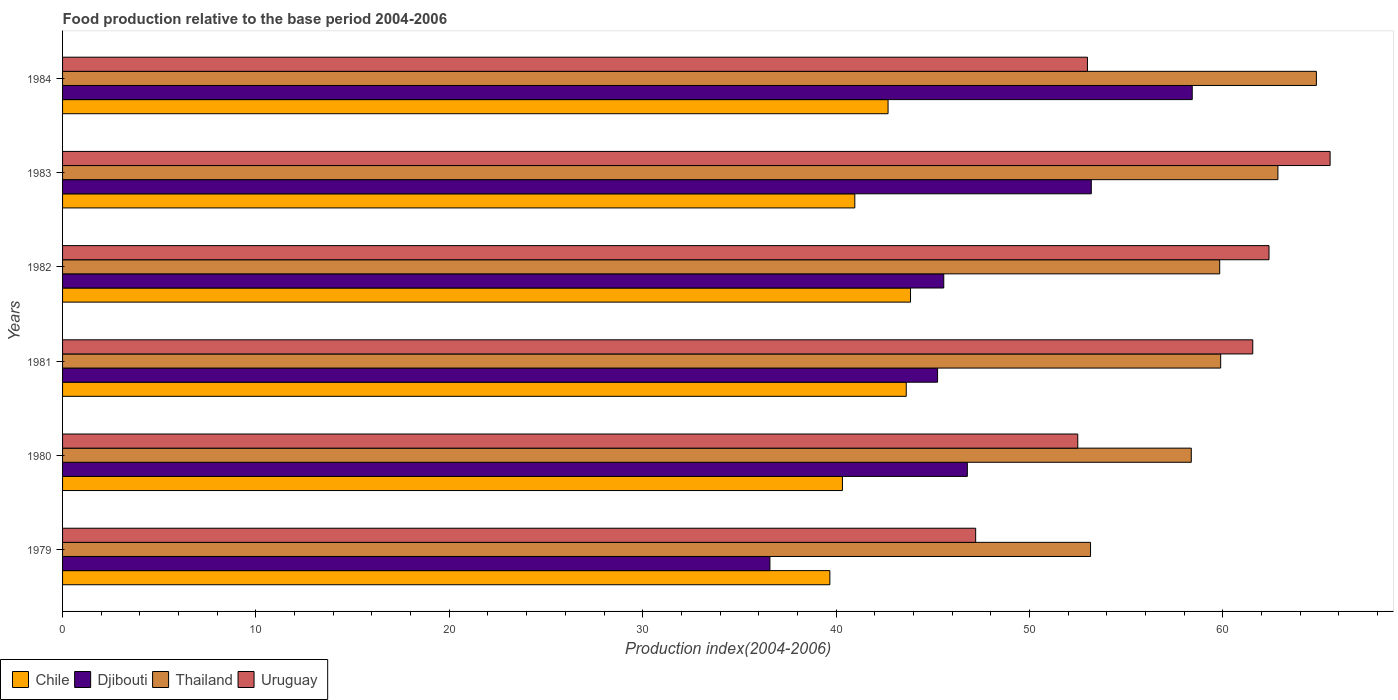How many different coloured bars are there?
Give a very brief answer. 4. Are the number of bars per tick equal to the number of legend labels?
Offer a terse response. Yes. Are the number of bars on each tick of the Y-axis equal?
Ensure brevity in your answer.  Yes. How many bars are there on the 3rd tick from the top?
Provide a succinct answer. 4. How many bars are there on the 6th tick from the bottom?
Offer a terse response. 4. In how many cases, is the number of bars for a given year not equal to the number of legend labels?
Your answer should be very brief. 0. What is the food production index in Chile in 1981?
Offer a terse response. 43.63. Across all years, what is the maximum food production index in Thailand?
Provide a short and direct response. 64.84. Across all years, what is the minimum food production index in Djibouti?
Provide a succinct answer. 36.58. In which year was the food production index in Chile minimum?
Keep it short and to the point. 1979. What is the total food production index in Thailand in the graph?
Provide a succinct answer. 358.95. What is the difference between the food production index in Uruguay in 1982 and that in 1983?
Your response must be concise. -3.16. What is the difference between the food production index in Chile in 1981 and the food production index in Djibouti in 1982?
Offer a very short reply. -1.94. What is the average food production index in Djibouti per year?
Give a very brief answer. 47.63. In the year 1983, what is the difference between the food production index in Djibouti and food production index in Uruguay?
Your response must be concise. -12.35. In how many years, is the food production index in Djibouti greater than 20 ?
Your answer should be very brief. 6. What is the ratio of the food production index in Uruguay in 1981 to that in 1983?
Make the answer very short. 0.94. What is the difference between the highest and the second highest food production index in Uruguay?
Offer a terse response. 3.16. What is the difference between the highest and the lowest food production index in Chile?
Make the answer very short. 4.17. Is the sum of the food production index in Uruguay in 1981 and 1982 greater than the maximum food production index in Djibouti across all years?
Give a very brief answer. Yes. Is it the case that in every year, the sum of the food production index in Uruguay and food production index in Djibouti is greater than the sum of food production index in Chile and food production index in Thailand?
Your answer should be very brief. No. What does the 3rd bar from the top in 1979 represents?
Make the answer very short. Djibouti. What does the 3rd bar from the bottom in 1984 represents?
Offer a very short reply. Thailand. What is the difference between two consecutive major ticks on the X-axis?
Give a very brief answer. 10. Are the values on the major ticks of X-axis written in scientific E-notation?
Keep it short and to the point. No. Does the graph contain any zero values?
Offer a terse response. No. Does the graph contain grids?
Keep it short and to the point. No. How are the legend labels stacked?
Keep it short and to the point. Horizontal. What is the title of the graph?
Your answer should be compact. Food production relative to the base period 2004-2006. Does "Lesotho" appear as one of the legend labels in the graph?
Make the answer very short. No. What is the label or title of the X-axis?
Your response must be concise. Production index(2004-2006). What is the label or title of the Y-axis?
Provide a short and direct response. Years. What is the Production index(2004-2006) in Chile in 1979?
Offer a terse response. 39.68. What is the Production index(2004-2006) in Djibouti in 1979?
Ensure brevity in your answer.  36.58. What is the Production index(2004-2006) in Thailand in 1979?
Provide a succinct answer. 53.16. What is the Production index(2004-2006) of Uruguay in 1979?
Keep it short and to the point. 47.22. What is the Production index(2004-2006) in Chile in 1980?
Provide a succinct answer. 40.33. What is the Production index(2004-2006) of Djibouti in 1980?
Ensure brevity in your answer.  46.79. What is the Production index(2004-2006) in Thailand in 1980?
Give a very brief answer. 58.37. What is the Production index(2004-2006) of Uruguay in 1980?
Offer a very short reply. 52.5. What is the Production index(2004-2006) of Chile in 1981?
Ensure brevity in your answer.  43.63. What is the Production index(2004-2006) of Djibouti in 1981?
Ensure brevity in your answer.  45.25. What is the Production index(2004-2006) of Thailand in 1981?
Make the answer very short. 59.89. What is the Production index(2004-2006) of Uruguay in 1981?
Make the answer very short. 61.55. What is the Production index(2004-2006) of Chile in 1982?
Provide a succinct answer. 43.85. What is the Production index(2004-2006) in Djibouti in 1982?
Your response must be concise. 45.57. What is the Production index(2004-2006) in Thailand in 1982?
Give a very brief answer. 59.84. What is the Production index(2004-2006) in Uruguay in 1982?
Offer a very short reply. 62.39. What is the Production index(2004-2006) of Chile in 1983?
Ensure brevity in your answer.  40.97. What is the Production index(2004-2006) in Djibouti in 1983?
Provide a short and direct response. 53.2. What is the Production index(2004-2006) of Thailand in 1983?
Your answer should be compact. 62.85. What is the Production index(2004-2006) in Uruguay in 1983?
Your answer should be compact. 65.55. What is the Production index(2004-2006) in Chile in 1984?
Make the answer very short. 42.69. What is the Production index(2004-2006) in Djibouti in 1984?
Keep it short and to the point. 58.42. What is the Production index(2004-2006) in Thailand in 1984?
Your answer should be very brief. 64.84. What is the Production index(2004-2006) in Uruguay in 1984?
Ensure brevity in your answer.  53. Across all years, what is the maximum Production index(2004-2006) of Chile?
Keep it short and to the point. 43.85. Across all years, what is the maximum Production index(2004-2006) of Djibouti?
Provide a succinct answer. 58.42. Across all years, what is the maximum Production index(2004-2006) of Thailand?
Provide a short and direct response. 64.84. Across all years, what is the maximum Production index(2004-2006) of Uruguay?
Your answer should be compact. 65.55. Across all years, what is the minimum Production index(2004-2006) in Chile?
Your response must be concise. 39.68. Across all years, what is the minimum Production index(2004-2006) of Djibouti?
Offer a very short reply. 36.58. Across all years, what is the minimum Production index(2004-2006) in Thailand?
Keep it short and to the point. 53.16. Across all years, what is the minimum Production index(2004-2006) in Uruguay?
Your answer should be very brief. 47.22. What is the total Production index(2004-2006) in Chile in the graph?
Your answer should be compact. 251.15. What is the total Production index(2004-2006) of Djibouti in the graph?
Make the answer very short. 285.81. What is the total Production index(2004-2006) of Thailand in the graph?
Provide a succinct answer. 358.95. What is the total Production index(2004-2006) in Uruguay in the graph?
Offer a very short reply. 342.21. What is the difference between the Production index(2004-2006) of Chile in 1979 and that in 1980?
Keep it short and to the point. -0.65. What is the difference between the Production index(2004-2006) of Djibouti in 1979 and that in 1980?
Your answer should be compact. -10.21. What is the difference between the Production index(2004-2006) of Thailand in 1979 and that in 1980?
Provide a short and direct response. -5.21. What is the difference between the Production index(2004-2006) in Uruguay in 1979 and that in 1980?
Your answer should be compact. -5.28. What is the difference between the Production index(2004-2006) in Chile in 1979 and that in 1981?
Provide a succinct answer. -3.95. What is the difference between the Production index(2004-2006) in Djibouti in 1979 and that in 1981?
Make the answer very short. -8.67. What is the difference between the Production index(2004-2006) in Thailand in 1979 and that in 1981?
Keep it short and to the point. -6.73. What is the difference between the Production index(2004-2006) of Uruguay in 1979 and that in 1981?
Your answer should be compact. -14.33. What is the difference between the Production index(2004-2006) in Chile in 1979 and that in 1982?
Your response must be concise. -4.17. What is the difference between the Production index(2004-2006) in Djibouti in 1979 and that in 1982?
Your answer should be compact. -8.99. What is the difference between the Production index(2004-2006) of Thailand in 1979 and that in 1982?
Ensure brevity in your answer.  -6.68. What is the difference between the Production index(2004-2006) in Uruguay in 1979 and that in 1982?
Your answer should be compact. -15.17. What is the difference between the Production index(2004-2006) in Chile in 1979 and that in 1983?
Ensure brevity in your answer.  -1.29. What is the difference between the Production index(2004-2006) of Djibouti in 1979 and that in 1983?
Your response must be concise. -16.62. What is the difference between the Production index(2004-2006) of Thailand in 1979 and that in 1983?
Your answer should be compact. -9.69. What is the difference between the Production index(2004-2006) in Uruguay in 1979 and that in 1983?
Offer a terse response. -18.33. What is the difference between the Production index(2004-2006) in Chile in 1979 and that in 1984?
Your answer should be compact. -3.01. What is the difference between the Production index(2004-2006) in Djibouti in 1979 and that in 1984?
Your answer should be compact. -21.84. What is the difference between the Production index(2004-2006) of Thailand in 1979 and that in 1984?
Keep it short and to the point. -11.68. What is the difference between the Production index(2004-2006) of Uruguay in 1979 and that in 1984?
Provide a short and direct response. -5.78. What is the difference between the Production index(2004-2006) of Chile in 1980 and that in 1981?
Give a very brief answer. -3.3. What is the difference between the Production index(2004-2006) in Djibouti in 1980 and that in 1981?
Give a very brief answer. 1.54. What is the difference between the Production index(2004-2006) of Thailand in 1980 and that in 1981?
Provide a succinct answer. -1.52. What is the difference between the Production index(2004-2006) in Uruguay in 1980 and that in 1981?
Give a very brief answer. -9.05. What is the difference between the Production index(2004-2006) in Chile in 1980 and that in 1982?
Your answer should be compact. -3.52. What is the difference between the Production index(2004-2006) in Djibouti in 1980 and that in 1982?
Provide a short and direct response. 1.22. What is the difference between the Production index(2004-2006) of Thailand in 1980 and that in 1982?
Give a very brief answer. -1.47. What is the difference between the Production index(2004-2006) in Uruguay in 1980 and that in 1982?
Ensure brevity in your answer.  -9.89. What is the difference between the Production index(2004-2006) in Chile in 1980 and that in 1983?
Provide a succinct answer. -0.64. What is the difference between the Production index(2004-2006) in Djibouti in 1980 and that in 1983?
Give a very brief answer. -6.41. What is the difference between the Production index(2004-2006) in Thailand in 1980 and that in 1983?
Provide a short and direct response. -4.48. What is the difference between the Production index(2004-2006) in Uruguay in 1980 and that in 1983?
Keep it short and to the point. -13.05. What is the difference between the Production index(2004-2006) of Chile in 1980 and that in 1984?
Your answer should be very brief. -2.36. What is the difference between the Production index(2004-2006) of Djibouti in 1980 and that in 1984?
Your answer should be very brief. -11.63. What is the difference between the Production index(2004-2006) in Thailand in 1980 and that in 1984?
Provide a short and direct response. -6.47. What is the difference between the Production index(2004-2006) of Chile in 1981 and that in 1982?
Provide a short and direct response. -0.22. What is the difference between the Production index(2004-2006) in Djibouti in 1981 and that in 1982?
Provide a short and direct response. -0.32. What is the difference between the Production index(2004-2006) in Thailand in 1981 and that in 1982?
Keep it short and to the point. 0.05. What is the difference between the Production index(2004-2006) in Uruguay in 1981 and that in 1982?
Offer a very short reply. -0.84. What is the difference between the Production index(2004-2006) in Chile in 1981 and that in 1983?
Give a very brief answer. 2.66. What is the difference between the Production index(2004-2006) in Djibouti in 1981 and that in 1983?
Offer a very short reply. -7.95. What is the difference between the Production index(2004-2006) in Thailand in 1981 and that in 1983?
Offer a very short reply. -2.96. What is the difference between the Production index(2004-2006) in Djibouti in 1981 and that in 1984?
Make the answer very short. -13.17. What is the difference between the Production index(2004-2006) of Thailand in 1981 and that in 1984?
Ensure brevity in your answer.  -4.95. What is the difference between the Production index(2004-2006) in Uruguay in 1981 and that in 1984?
Ensure brevity in your answer.  8.55. What is the difference between the Production index(2004-2006) in Chile in 1982 and that in 1983?
Keep it short and to the point. 2.88. What is the difference between the Production index(2004-2006) in Djibouti in 1982 and that in 1983?
Your answer should be compact. -7.63. What is the difference between the Production index(2004-2006) of Thailand in 1982 and that in 1983?
Keep it short and to the point. -3.01. What is the difference between the Production index(2004-2006) in Uruguay in 1982 and that in 1983?
Provide a short and direct response. -3.16. What is the difference between the Production index(2004-2006) in Chile in 1982 and that in 1984?
Make the answer very short. 1.16. What is the difference between the Production index(2004-2006) of Djibouti in 1982 and that in 1984?
Keep it short and to the point. -12.85. What is the difference between the Production index(2004-2006) in Thailand in 1982 and that in 1984?
Offer a terse response. -5. What is the difference between the Production index(2004-2006) in Uruguay in 1982 and that in 1984?
Give a very brief answer. 9.39. What is the difference between the Production index(2004-2006) in Chile in 1983 and that in 1984?
Your answer should be compact. -1.72. What is the difference between the Production index(2004-2006) of Djibouti in 1983 and that in 1984?
Make the answer very short. -5.22. What is the difference between the Production index(2004-2006) in Thailand in 1983 and that in 1984?
Make the answer very short. -1.99. What is the difference between the Production index(2004-2006) of Uruguay in 1983 and that in 1984?
Offer a very short reply. 12.55. What is the difference between the Production index(2004-2006) in Chile in 1979 and the Production index(2004-2006) in Djibouti in 1980?
Make the answer very short. -7.11. What is the difference between the Production index(2004-2006) in Chile in 1979 and the Production index(2004-2006) in Thailand in 1980?
Keep it short and to the point. -18.69. What is the difference between the Production index(2004-2006) in Chile in 1979 and the Production index(2004-2006) in Uruguay in 1980?
Ensure brevity in your answer.  -12.82. What is the difference between the Production index(2004-2006) in Djibouti in 1979 and the Production index(2004-2006) in Thailand in 1980?
Provide a succinct answer. -21.79. What is the difference between the Production index(2004-2006) in Djibouti in 1979 and the Production index(2004-2006) in Uruguay in 1980?
Keep it short and to the point. -15.92. What is the difference between the Production index(2004-2006) of Thailand in 1979 and the Production index(2004-2006) of Uruguay in 1980?
Make the answer very short. 0.66. What is the difference between the Production index(2004-2006) in Chile in 1979 and the Production index(2004-2006) in Djibouti in 1981?
Provide a short and direct response. -5.57. What is the difference between the Production index(2004-2006) in Chile in 1979 and the Production index(2004-2006) in Thailand in 1981?
Your answer should be compact. -20.21. What is the difference between the Production index(2004-2006) of Chile in 1979 and the Production index(2004-2006) of Uruguay in 1981?
Provide a short and direct response. -21.87. What is the difference between the Production index(2004-2006) of Djibouti in 1979 and the Production index(2004-2006) of Thailand in 1981?
Your response must be concise. -23.31. What is the difference between the Production index(2004-2006) of Djibouti in 1979 and the Production index(2004-2006) of Uruguay in 1981?
Your response must be concise. -24.97. What is the difference between the Production index(2004-2006) in Thailand in 1979 and the Production index(2004-2006) in Uruguay in 1981?
Your response must be concise. -8.39. What is the difference between the Production index(2004-2006) in Chile in 1979 and the Production index(2004-2006) in Djibouti in 1982?
Your response must be concise. -5.89. What is the difference between the Production index(2004-2006) of Chile in 1979 and the Production index(2004-2006) of Thailand in 1982?
Provide a succinct answer. -20.16. What is the difference between the Production index(2004-2006) in Chile in 1979 and the Production index(2004-2006) in Uruguay in 1982?
Your answer should be very brief. -22.71. What is the difference between the Production index(2004-2006) in Djibouti in 1979 and the Production index(2004-2006) in Thailand in 1982?
Offer a terse response. -23.26. What is the difference between the Production index(2004-2006) in Djibouti in 1979 and the Production index(2004-2006) in Uruguay in 1982?
Offer a terse response. -25.81. What is the difference between the Production index(2004-2006) of Thailand in 1979 and the Production index(2004-2006) of Uruguay in 1982?
Give a very brief answer. -9.23. What is the difference between the Production index(2004-2006) in Chile in 1979 and the Production index(2004-2006) in Djibouti in 1983?
Keep it short and to the point. -13.52. What is the difference between the Production index(2004-2006) in Chile in 1979 and the Production index(2004-2006) in Thailand in 1983?
Your response must be concise. -23.17. What is the difference between the Production index(2004-2006) in Chile in 1979 and the Production index(2004-2006) in Uruguay in 1983?
Ensure brevity in your answer.  -25.87. What is the difference between the Production index(2004-2006) of Djibouti in 1979 and the Production index(2004-2006) of Thailand in 1983?
Offer a terse response. -26.27. What is the difference between the Production index(2004-2006) in Djibouti in 1979 and the Production index(2004-2006) in Uruguay in 1983?
Provide a succinct answer. -28.97. What is the difference between the Production index(2004-2006) in Thailand in 1979 and the Production index(2004-2006) in Uruguay in 1983?
Ensure brevity in your answer.  -12.39. What is the difference between the Production index(2004-2006) of Chile in 1979 and the Production index(2004-2006) of Djibouti in 1984?
Your response must be concise. -18.74. What is the difference between the Production index(2004-2006) of Chile in 1979 and the Production index(2004-2006) of Thailand in 1984?
Your answer should be compact. -25.16. What is the difference between the Production index(2004-2006) in Chile in 1979 and the Production index(2004-2006) in Uruguay in 1984?
Give a very brief answer. -13.32. What is the difference between the Production index(2004-2006) in Djibouti in 1979 and the Production index(2004-2006) in Thailand in 1984?
Your answer should be compact. -28.26. What is the difference between the Production index(2004-2006) of Djibouti in 1979 and the Production index(2004-2006) of Uruguay in 1984?
Provide a succinct answer. -16.42. What is the difference between the Production index(2004-2006) of Thailand in 1979 and the Production index(2004-2006) of Uruguay in 1984?
Your answer should be compact. 0.16. What is the difference between the Production index(2004-2006) in Chile in 1980 and the Production index(2004-2006) in Djibouti in 1981?
Give a very brief answer. -4.92. What is the difference between the Production index(2004-2006) of Chile in 1980 and the Production index(2004-2006) of Thailand in 1981?
Your response must be concise. -19.56. What is the difference between the Production index(2004-2006) in Chile in 1980 and the Production index(2004-2006) in Uruguay in 1981?
Ensure brevity in your answer.  -21.22. What is the difference between the Production index(2004-2006) of Djibouti in 1980 and the Production index(2004-2006) of Thailand in 1981?
Offer a very short reply. -13.1. What is the difference between the Production index(2004-2006) of Djibouti in 1980 and the Production index(2004-2006) of Uruguay in 1981?
Offer a terse response. -14.76. What is the difference between the Production index(2004-2006) in Thailand in 1980 and the Production index(2004-2006) in Uruguay in 1981?
Provide a succinct answer. -3.18. What is the difference between the Production index(2004-2006) of Chile in 1980 and the Production index(2004-2006) of Djibouti in 1982?
Ensure brevity in your answer.  -5.24. What is the difference between the Production index(2004-2006) of Chile in 1980 and the Production index(2004-2006) of Thailand in 1982?
Give a very brief answer. -19.51. What is the difference between the Production index(2004-2006) of Chile in 1980 and the Production index(2004-2006) of Uruguay in 1982?
Offer a terse response. -22.06. What is the difference between the Production index(2004-2006) in Djibouti in 1980 and the Production index(2004-2006) in Thailand in 1982?
Provide a short and direct response. -13.05. What is the difference between the Production index(2004-2006) of Djibouti in 1980 and the Production index(2004-2006) of Uruguay in 1982?
Keep it short and to the point. -15.6. What is the difference between the Production index(2004-2006) in Thailand in 1980 and the Production index(2004-2006) in Uruguay in 1982?
Offer a very short reply. -4.02. What is the difference between the Production index(2004-2006) in Chile in 1980 and the Production index(2004-2006) in Djibouti in 1983?
Offer a terse response. -12.87. What is the difference between the Production index(2004-2006) of Chile in 1980 and the Production index(2004-2006) of Thailand in 1983?
Offer a terse response. -22.52. What is the difference between the Production index(2004-2006) in Chile in 1980 and the Production index(2004-2006) in Uruguay in 1983?
Ensure brevity in your answer.  -25.22. What is the difference between the Production index(2004-2006) of Djibouti in 1980 and the Production index(2004-2006) of Thailand in 1983?
Keep it short and to the point. -16.06. What is the difference between the Production index(2004-2006) of Djibouti in 1980 and the Production index(2004-2006) of Uruguay in 1983?
Make the answer very short. -18.76. What is the difference between the Production index(2004-2006) in Thailand in 1980 and the Production index(2004-2006) in Uruguay in 1983?
Ensure brevity in your answer.  -7.18. What is the difference between the Production index(2004-2006) of Chile in 1980 and the Production index(2004-2006) of Djibouti in 1984?
Keep it short and to the point. -18.09. What is the difference between the Production index(2004-2006) in Chile in 1980 and the Production index(2004-2006) in Thailand in 1984?
Provide a short and direct response. -24.51. What is the difference between the Production index(2004-2006) in Chile in 1980 and the Production index(2004-2006) in Uruguay in 1984?
Your answer should be very brief. -12.67. What is the difference between the Production index(2004-2006) in Djibouti in 1980 and the Production index(2004-2006) in Thailand in 1984?
Offer a very short reply. -18.05. What is the difference between the Production index(2004-2006) in Djibouti in 1980 and the Production index(2004-2006) in Uruguay in 1984?
Your answer should be compact. -6.21. What is the difference between the Production index(2004-2006) of Thailand in 1980 and the Production index(2004-2006) of Uruguay in 1984?
Offer a terse response. 5.37. What is the difference between the Production index(2004-2006) of Chile in 1981 and the Production index(2004-2006) of Djibouti in 1982?
Your response must be concise. -1.94. What is the difference between the Production index(2004-2006) of Chile in 1981 and the Production index(2004-2006) of Thailand in 1982?
Ensure brevity in your answer.  -16.21. What is the difference between the Production index(2004-2006) in Chile in 1981 and the Production index(2004-2006) in Uruguay in 1982?
Your answer should be compact. -18.76. What is the difference between the Production index(2004-2006) of Djibouti in 1981 and the Production index(2004-2006) of Thailand in 1982?
Give a very brief answer. -14.59. What is the difference between the Production index(2004-2006) of Djibouti in 1981 and the Production index(2004-2006) of Uruguay in 1982?
Offer a terse response. -17.14. What is the difference between the Production index(2004-2006) of Chile in 1981 and the Production index(2004-2006) of Djibouti in 1983?
Give a very brief answer. -9.57. What is the difference between the Production index(2004-2006) of Chile in 1981 and the Production index(2004-2006) of Thailand in 1983?
Your response must be concise. -19.22. What is the difference between the Production index(2004-2006) of Chile in 1981 and the Production index(2004-2006) of Uruguay in 1983?
Your response must be concise. -21.92. What is the difference between the Production index(2004-2006) of Djibouti in 1981 and the Production index(2004-2006) of Thailand in 1983?
Ensure brevity in your answer.  -17.6. What is the difference between the Production index(2004-2006) in Djibouti in 1981 and the Production index(2004-2006) in Uruguay in 1983?
Offer a very short reply. -20.3. What is the difference between the Production index(2004-2006) in Thailand in 1981 and the Production index(2004-2006) in Uruguay in 1983?
Offer a terse response. -5.66. What is the difference between the Production index(2004-2006) of Chile in 1981 and the Production index(2004-2006) of Djibouti in 1984?
Your response must be concise. -14.79. What is the difference between the Production index(2004-2006) of Chile in 1981 and the Production index(2004-2006) of Thailand in 1984?
Give a very brief answer. -21.21. What is the difference between the Production index(2004-2006) of Chile in 1981 and the Production index(2004-2006) of Uruguay in 1984?
Offer a terse response. -9.37. What is the difference between the Production index(2004-2006) in Djibouti in 1981 and the Production index(2004-2006) in Thailand in 1984?
Offer a terse response. -19.59. What is the difference between the Production index(2004-2006) in Djibouti in 1981 and the Production index(2004-2006) in Uruguay in 1984?
Ensure brevity in your answer.  -7.75. What is the difference between the Production index(2004-2006) in Thailand in 1981 and the Production index(2004-2006) in Uruguay in 1984?
Keep it short and to the point. 6.89. What is the difference between the Production index(2004-2006) of Chile in 1982 and the Production index(2004-2006) of Djibouti in 1983?
Your answer should be very brief. -9.35. What is the difference between the Production index(2004-2006) in Chile in 1982 and the Production index(2004-2006) in Uruguay in 1983?
Your answer should be compact. -21.7. What is the difference between the Production index(2004-2006) in Djibouti in 1982 and the Production index(2004-2006) in Thailand in 1983?
Ensure brevity in your answer.  -17.28. What is the difference between the Production index(2004-2006) in Djibouti in 1982 and the Production index(2004-2006) in Uruguay in 1983?
Provide a short and direct response. -19.98. What is the difference between the Production index(2004-2006) in Thailand in 1982 and the Production index(2004-2006) in Uruguay in 1983?
Give a very brief answer. -5.71. What is the difference between the Production index(2004-2006) in Chile in 1982 and the Production index(2004-2006) in Djibouti in 1984?
Offer a very short reply. -14.57. What is the difference between the Production index(2004-2006) of Chile in 1982 and the Production index(2004-2006) of Thailand in 1984?
Offer a terse response. -20.99. What is the difference between the Production index(2004-2006) of Chile in 1982 and the Production index(2004-2006) of Uruguay in 1984?
Offer a terse response. -9.15. What is the difference between the Production index(2004-2006) in Djibouti in 1982 and the Production index(2004-2006) in Thailand in 1984?
Your answer should be compact. -19.27. What is the difference between the Production index(2004-2006) in Djibouti in 1982 and the Production index(2004-2006) in Uruguay in 1984?
Give a very brief answer. -7.43. What is the difference between the Production index(2004-2006) of Thailand in 1982 and the Production index(2004-2006) of Uruguay in 1984?
Your answer should be compact. 6.84. What is the difference between the Production index(2004-2006) in Chile in 1983 and the Production index(2004-2006) in Djibouti in 1984?
Offer a terse response. -17.45. What is the difference between the Production index(2004-2006) in Chile in 1983 and the Production index(2004-2006) in Thailand in 1984?
Offer a very short reply. -23.87. What is the difference between the Production index(2004-2006) of Chile in 1983 and the Production index(2004-2006) of Uruguay in 1984?
Give a very brief answer. -12.03. What is the difference between the Production index(2004-2006) in Djibouti in 1983 and the Production index(2004-2006) in Thailand in 1984?
Provide a succinct answer. -11.64. What is the difference between the Production index(2004-2006) of Thailand in 1983 and the Production index(2004-2006) of Uruguay in 1984?
Keep it short and to the point. 9.85. What is the average Production index(2004-2006) in Chile per year?
Provide a succinct answer. 41.86. What is the average Production index(2004-2006) in Djibouti per year?
Provide a short and direct response. 47.63. What is the average Production index(2004-2006) in Thailand per year?
Give a very brief answer. 59.83. What is the average Production index(2004-2006) of Uruguay per year?
Your response must be concise. 57.03. In the year 1979, what is the difference between the Production index(2004-2006) in Chile and Production index(2004-2006) in Thailand?
Your response must be concise. -13.48. In the year 1979, what is the difference between the Production index(2004-2006) of Chile and Production index(2004-2006) of Uruguay?
Your response must be concise. -7.54. In the year 1979, what is the difference between the Production index(2004-2006) in Djibouti and Production index(2004-2006) in Thailand?
Your response must be concise. -16.58. In the year 1979, what is the difference between the Production index(2004-2006) of Djibouti and Production index(2004-2006) of Uruguay?
Your response must be concise. -10.64. In the year 1979, what is the difference between the Production index(2004-2006) in Thailand and Production index(2004-2006) in Uruguay?
Ensure brevity in your answer.  5.94. In the year 1980, what is the difference between the Production index(2004-2006) in Chile and Production index(2004-2006) in Djibouti?
Give a very brief answer. -6.46. In the year 1980, what is the difference between the Production index(2004-2006) of Chile and Production index(2004-2006) of Thailand?
Provide a succinct answer. -18.04. In the year 1980, what is the difference between the Production index(2004-2006) of Chile and Production index(2004-2006) of Uruguay?
Offer a very short reply. -12.17. In the year 1980, what is the difference between the Production index(2004-2006) in Djibouti and Production index(2004-2006) in Thailand?
Make the answer very short. -11.58. In the year 1980, what is the difference between the Production index(2004-2006) in Djibouti and Production index(2004-2006) in Uruguay?
Ensure brevity in your answer.  -5.71. In the year 1980, what is the difference between the Production index(2004-2006) in Thailand and Production index(2004-2006) in Uruguay?
Offer a terse response. 5.87. In the year 1981, what is the difference between the Production index(2004-2006) in Chile and Production index(2004-2006) in Djibouti?
Keep it short and to the point. -1.62. In the year 1981, what is the difference between the Production index(2004-2006) in Chile and Production index(2004-2006) in Thailand?
Give a very brief answer. -16.26. In the year 1981, what is the difference between the Production index(2004-2006) in Chile and Production index(2004-2006) in Uruguay?
Offer a terse response. -17.92. In the year 1981, what is the difference between the Production index(2004-2006) of Djibouti and Production index(2004-2006) of Thailand?
Keep it short and to the point. -14.64. In the year 1981, what is the difference between the Production index(2004-2006) of Djibouti and Production index(2004-2006) of Uruguay?
Provide a succinct answer. -16.3. In the year 1981, what is the difference between the Production index(2004-2006) of Thailand and Production index(2004-2006) of Uruguay?
Offer a very short reply. -1.66. In the year 1982, what is the difference between the Production index(2004-2006) of Chile and Production index(2004-2006) of Djibouti?
Offer a very short reply. -1.72. In the year 1982, what is the difference between the Production index(2004-2006) of Chile and Production index(2004-2006) of Thailand?
Ensure brevity in your answer.  -15.99. In the year 1982, what is the difference between the Production index(2004-2006) of Chile and Production index(2004-2006) of Uruguay?
Offer a very short reply. -18.54. In the year 1982, what is the difference between the Production index(2004-2006) of Djibouti and Production index(2004-2006) of Thailand?
Provide a short and direct response. -14.27. In the year 1982, what is the difference between the Production index(2004-2006) in Djibouti and Production index(2004-2006) in Uruguay?
Provide a short and direct response. -16.82. In the year 1982, what is the difference between the Production index(2004-2006) of Thailand and Production index(2004-2006) of Uruguay?
Your answer should be very brief. -2.55. In the year 1983, what is the difference between the Production index(2004-2006) in Chile and Production index(2004-2006) in Djibouti?
Give a very brief answer. -12.23. In the year 1983, what is the difference between the Production index(2004-2006) in Chile and Production index(2004-2006) in Thailand?
Provide a succinct answer. -21.88. In the year 1983, what is the difference between the Production index(2004-2006) in Chile and Production index(2004-2006) in Uruguay?
Your answer should be compact. -24.58. In the year 1983, what is the difference between the Production index(2004-2006) in Djibouti and Production index(2004-2006) in Thailand?
Offer a terse response. -9.65. In the year 1983, what is the difference between the Production index(2004-2006) of Djibouti and Production index(2004-2006) of Uruguay?
Your answer should be very brief. -12.35. In the year 1983, what is the difference between the Production index(2004-2006) in Thailand and Production index(2004-2006) in Uruguay?
Provide a succinct answer. -2.7. In the year 1984, what is the difference between the Production index(2004-2006) of Chile and Production index(2004-2006) of Djibouti?
Your answer should be very brief. -15.73. In the year 1984, what is the difference between the Production index(2004-2006) of Chile and Production index(2004-2006) of Thailand?
Give a very brief answer. -22.15. In the year 1984, what is the difference between the Production index(2004-2006) in Chile and Production index(2004-2006) in Uruguay?
Your response must be concise. -10.31. In the year 1984, what is the difference between the Production index(2004-2006) in Djibouti and Production index(2004-2006) in Thailand?
Offer a very short reply. -6.42. In the year 1984, what is the difference between the Production index(2004-2006) in Djibouti and Production index(2004-2006) in Uruguay?
Give a very brief answer. 5.42. In the year 1984, what is the difference between the Production index(2004-2006) of Thailand and Production index(2004-2006) of Uruguay?
Offer a terse response. 11.84. What is the ratio of the Production index(2004-2006) of Chile in 1979 to that in 1980?
Give a very brief answer. 0.98. What is the ratio of the Production index(2004-2006) in Djibouti in 1979 to that in 1980?
Offer a very short reply. 0.78. What is the ratio of the Production index(2004-2006) in Thailand in 1979 to that in 1980?
Make the answer very short. 0.91. What is the ratio of the Production index(2004-2006) of Uruguay in 1979 to that in 1980?
Make the answer very short. 0.9. What is the ratio of the Production index(2004-2006) in Chile in 1979 to that in 1981?
Ensure brevity in your answer.  0.91. What is the ratio of the Production index(2004-2006) of Djibouti in 1979 to that in 1981?
Ensure brevity in your answer.  0.81. What is the ratio of the Production index(2004-2006) of Thailand in 1979 to that in 1981?
Offer a very short reply. 0.89. What is the ratio of the Production index(2004-2006) of Uruguay in 1979 to that in 1981?
Your response must be concise. 0.77. What is the ratio of the Production index(2004-2006) in Chile in 1979 to that in 1982?
Offer a terse response. 0.9. What is the ratio of the Production index(2004-2006) of Djibouti in 1979 to that in 1982?
Give a very brief answer. 0.8. What is the ratio of the Production index(2004-2006) in Thailand in 1979 to that in 1982?
Ensure brevity in your answer.  0.89. What is the ratio of the Production index(2004-2006) of Uruguay in 1979 to that in 1982?
Provide a short and direct response. 0.76. What is the ratio of the Production index(2004-2006) in Chile in 1979 to that in 1983?
Keep it short and to the point. 0.97. What is the ratio of the Production index(2004-2006) in Djibouti in 1979 to that in 1983?
Your response must be concise. 0.69. What is the ratio of the Production index(2004-2006) of Thailand in 1979 to that in 1983?
Your response must be concise. 0.85. What is the ratio of the Production index(2004-2006) in Uruguay in 1979 to that in 1983?
Keep it short and to the point. 0.72. What is the ratio of the Production index(2004-2006) of Chile in 1979 to that in 1984?
Offer a very short reply. 0.93. What is the ratio of the Production index(2004-2006) in Djibouti in 1979 to that in 1984?
Keep it short and to the point. 0.63. What is the ratio of the Production index(2004-2006) in Thailand in 1979 to that in 1984?
Your answer should be very brief. 0.82. What is the ratio of the Production index(2004-2006) of Uruguay in 1979 to that in 1984?
Provide a succinct answer. 0.89. What is the ratio of the Production index(2004-2006) in Chile in 1980 to that in 1981?
Provide a short and direct response. 0.92. What is the ratio of the Production index(2004-2006) of Djibouti in 1980 to that in 1981?
Make the answer very short. 1.03. What is the ratio of the Production index(2004-2006) of Thailand in 1980 to that in 1981?
Keep it short and to the point. 0.97. What is the ratio of the Production index(2004-2006) of Uruguay in 1980 to that in 1981?
Give a very brief answer. 0.85. What is the ratio of the Production index(2004-2006) of Chile in 1980 to that in 1982?
Your answer should be very brief. 0.92. What is the ratio of the Production index(2004-2006) of Djibouti in 1980 to that in 1982?
Provide a succinct answer. 1.03. What is the ratio of the Production index(2004-2006) in Thailand in 1980 to that in 1982?
Your response must be concise. 0.98. What is the ratio of the Production index(2004-2006) in Uruguay in 1980 to that in 1982?
Make the answer very short. 0.84. What is the ratio of the Production index(2004-2006) of Chile in 1980 to that in 1983?
Your answer should be compact. 0.98. What is the ratio of the Production index(2004-2006) of Djibouti in 1980 to that in 1983?
Offer a terse response. 0.88. What is the ratio of the Production index(2004-2006) of Thailand in 1980 to that in 1983?
Your answer should be very brief. 0.93. What is the ratio of the Production index(2004-2006) of Uruguay in 1980 to that in 1983?
Your answer should be very brief. 0.8. What is the ratio of the Production index(2004-2006) of Chile in 1980 to that in 1984?
Ensure brevity in your answer.  0.94. What is the ratio of the Production index(2004-2006) of Djibouti in 1980 to that in 1984?
Provide a short and direct response. 0.8. What is the ratio of the Production index(2004-2006) in Thailand in 1980 to that in 1984?
Give a very brief answer. 0.9. What is the ratio of the Production index(2004-2006) in Uruguay in 1980 to that in 1984?
Provide a succinct answer. 0.99. What is the ratio of the Production index(2004-2006) in Djibouti in 1981 to that in 1982?
Your response must be concise. 0.99. What is the ratio of the Production index(2004-2006) of Thailand in 1981 to that in 1982?
Provide a succinct answer. 1. What is the ratio of the Production index(2004-2006) in Uruguay in 1981 to that in 1982?
Give a very brief answer. 0.99. What is the ratio of the Production index(2004-2006) of Chile in 1981 to that in 1983?
Provide a short and direct response. 1.06. What is the ratio of the Production index(2004-2006) in Djibouti in 1981 to that in 1983?
Keep it short and to the point. 0.85. What is the ratio of the Production index(2004-2006) in Thailand in 1981 to that in 1983?
Offer a terse response. 0.95. What is the ratio of the Production index(2004-2006) in Uruguay in 1981 to that in 1983?
Ensure brevity in your answer.  0.94. What is the ratio of the Production index(2004-2006) in Chile in 1981 to that in 1984?
Your answer should be compact. 1.02. What is the ratio of the Production index(2004-2006) of Djibouti in 1981 to that in 1984?
Give a very brief answer. 0.77. What is the ratio of the Production index(2004-2006) of Thailand in 1981 to that in 1984?
Give a very brief answer. 0.92. What is the ratio of the Production index(2004-2006) of Uruguay in 1981 to that in 1984?
Your response must be concise. 1.16. What is the ratio of the Production index(2004-2006) of Chile in 1982 to that in 1983?
Give a very brief answer. 1.07. What is the ratio of the Production index(2004-2006) in Djibouti in 1982 to that in 1983?
Provide a succinct answer. 0.86. What is the ratio of the Production index(2004-2006) in Thailand in 1982 to that in 1983?
Your answer should be compact. 0.95. What is the ratio of the Production index(2004-2006) in Uruguay in 1982 to that in 1983?
Ensure brevity in your answer.  0.95. What is the ratio of the Production index(2004-2006) of Chile in 1982 to that in 1984?
Offer a terse response. 1.03. What is the ratio of the Production index(2004-2006) of Djibouti in 1982 to that in 1984?
Ensure brevity in your answer.  0.78. What is the ratio of the Production index(2004-2006) of Thailand in 1982 to that in 1984?
Offer a terse response. 0.92. What is the ratio of the Production index(2004-2006) of Uruguay in 1982 to that in 1984?
Your answer should be compact. 1.18. What is the ratio of the Production index(2004-2006) of Chile in 1983 to that in 1984?
Offer a very short reply. 0.96. What is the ratio of the Production index(2004-2006) of Djibouti in 1983 to that in 1984?
Your answer should be very brief. 0.91. What is the ratio of the Production index(2004-2006) of Thailand in 1983 to that in 1984?
Give a very brief answer. 0.97. What is the ratio of the Production index(2004-2006) of Uruguay in 1983 to that in 1984?
Your answer should be compact. 1.24. What is the difference between the highest and the second highest Production index(2004-2006) of Chile?
Offer a terse response. 0.22. What is the difference between the highest and the second highest Production index(2004-2006) of Djibouti?
Provide a short and direct response. 5.22. What is the difference between the highest and the second highest Production index(2004-2006) of Thailand?
Keep it short and to the point. 1.99. What is the difference between the highest and the second highest Production index(2004-2006) in Uruguay?
Provide a succinct answer. 3.16. What is the difference between the highest and the lowest Production index(2004-2006) in Chile?
Ensure brevity in your answer.  4.17. What is the difference between the highest and the lowest Production index(2004-2006) of Djibouti?
Offer a terse response. 21.84. What is the difference between the highest and the lowest Production index(2004-2006) in Thailand?
Provide a succinct answer. 11.68. What is the difference between the highest and the lowest Production index(2004-2006) in Uruguay?
Give a very brief answer. 18.33. 